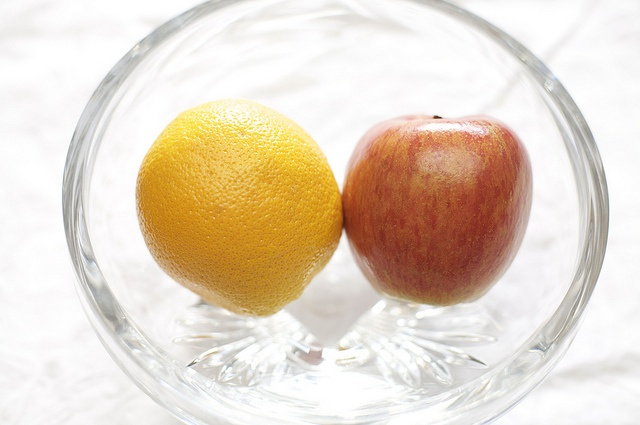Describe the objects in this image and their specific colors. I can see bowl in white, orange, brown, and darkgray tones, orange in white, orange, gold, and tan tones, and apple in white, brown, and tan tones in this image. 